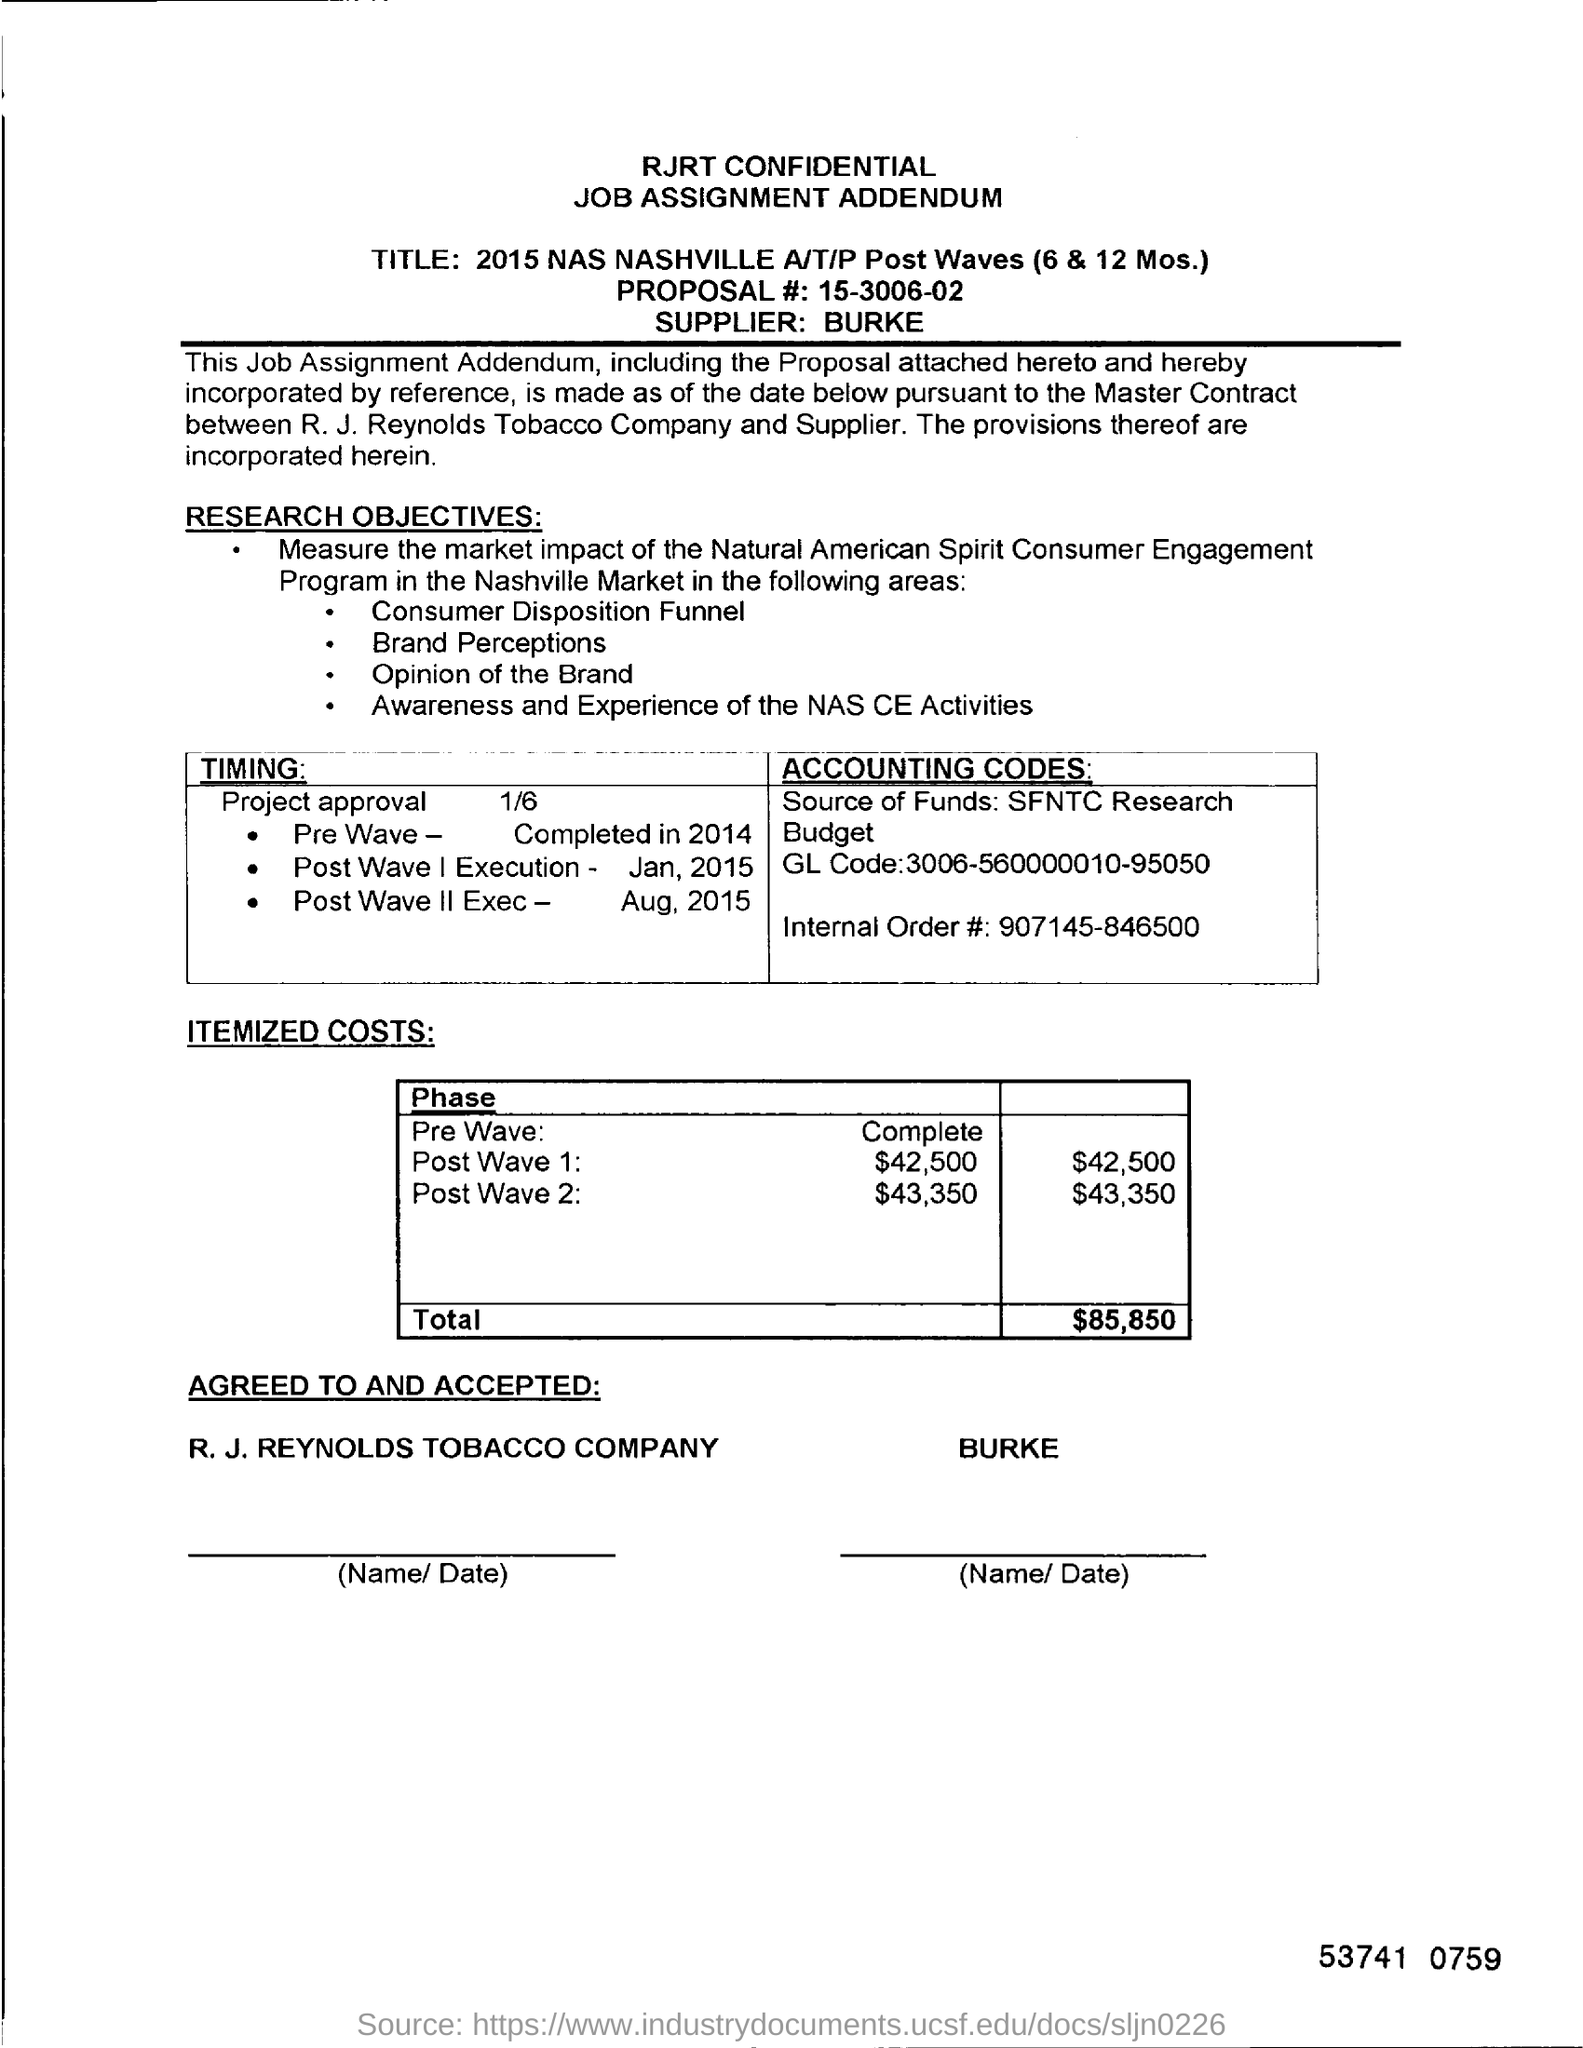Who is the supplier?
Your response must be concise. Burke. What is the itemized costs Total?
Offer a terse response. $85,850. What is the itemized costs for Post Wave1?
Provide a succinct answer. $42,500. 